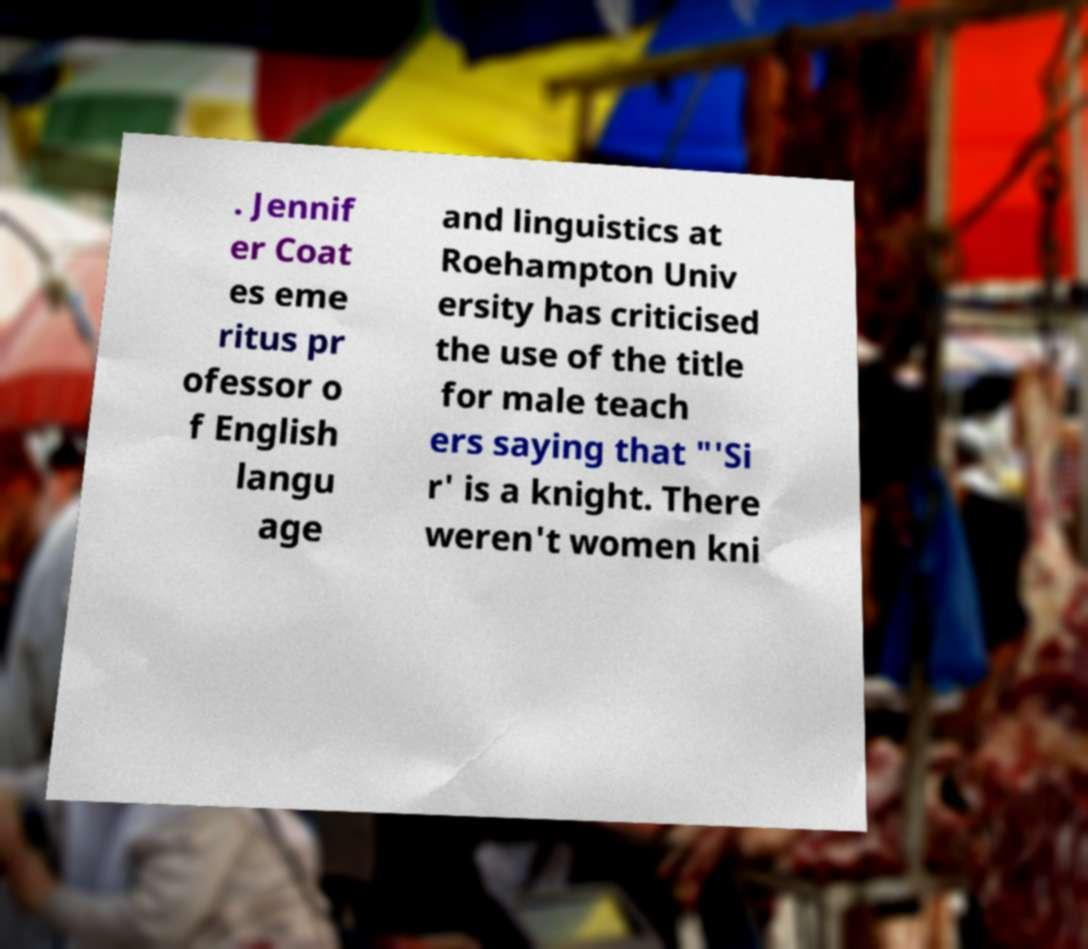What messages or text are displayed in this image? I need them in a readable, typed format. . Jennif er Coat es eme ritus pr ofessor o f English langu age and linguistics at Roehampton Univ ersity has criticised the use of the title for male teach ers saying that "'Si r' is a knight. There weren't women kni 